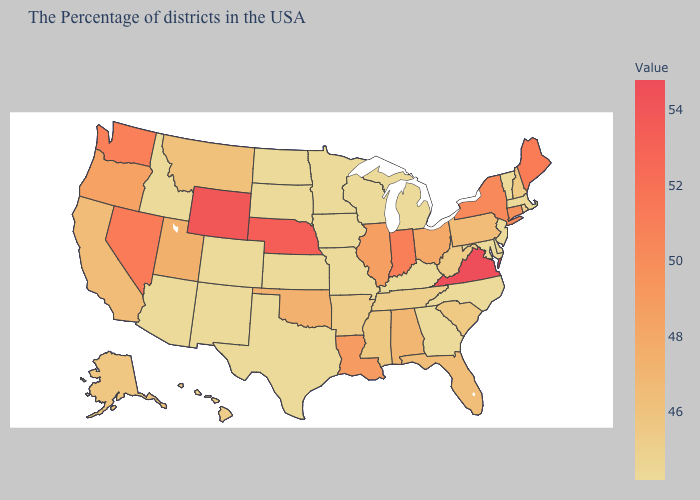Does Kansas have a higher value than Oklahoma?
Quick response, please. No. Does Montana have the highest value in the USA?
Be succinct. No. Is the legend a continuous bar?
Answer briefly. Yes. Does the map have missing data?
Short answer required. No. Is the legend a continuous bar?
Keep it brief. Yes. Does Kansas have the lowest value in the USA?
Give a very brief answer. Yes. 